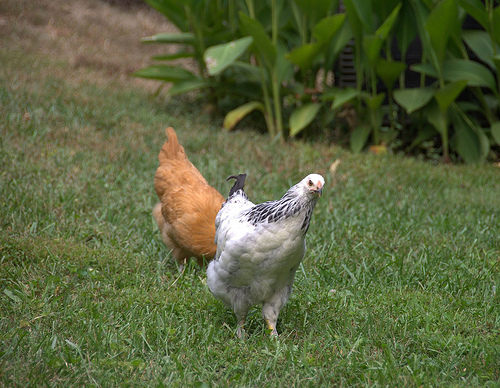<image>
Can you confirm if the chicken is next to the plant? No. The chicken is not positioned next to the plant. They are located in different areas of the scene. 